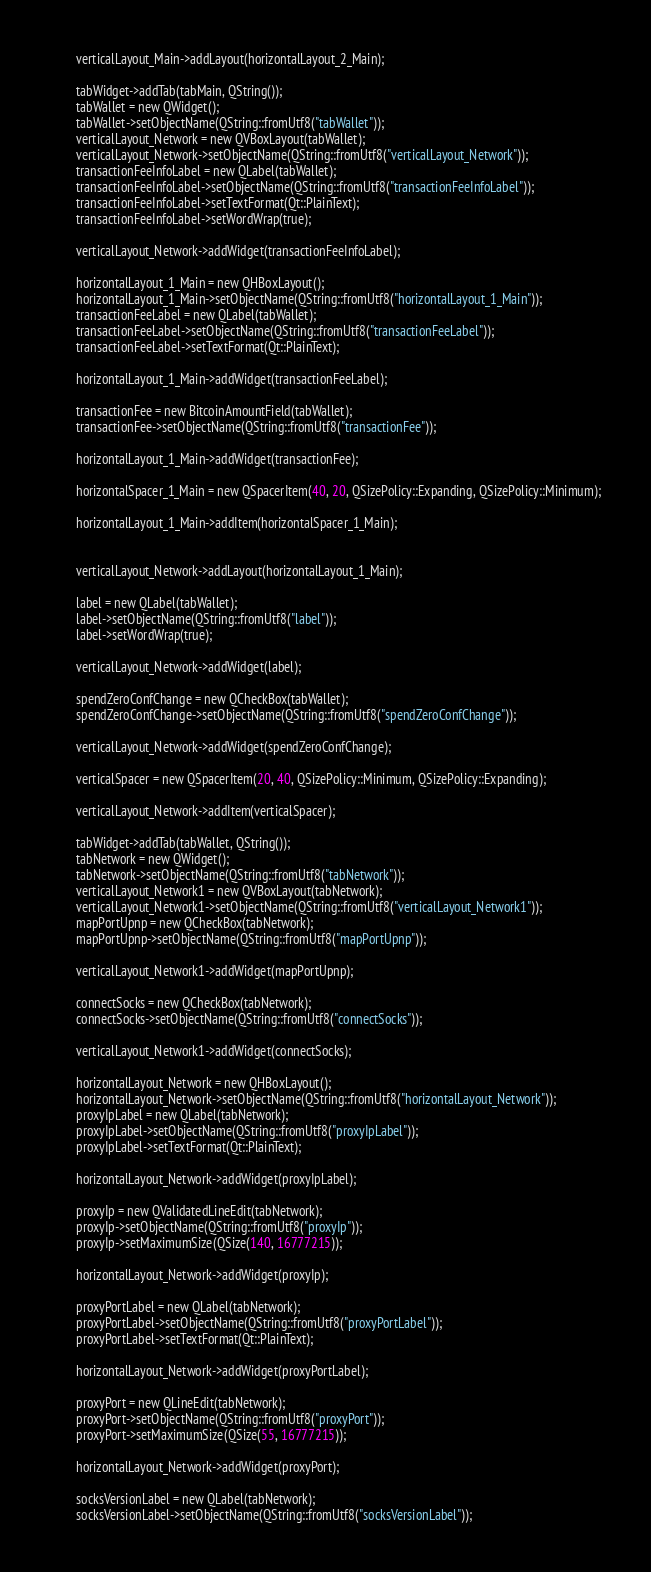Convert code to text. <code><loc_0><loc_0><loc_500><loc_500><_C_>        verticalLayout_Main->addLayout(horizontalLayout_2_Main);

        tabWidget->addTab(tabMain, QString());
        tabWallet = new QWidget();
        tabWallet->setObjectName(QString::fromUtf8("tabWallet"));
        verticalLayout_Network = new QVBoxLayout(tabWallet);
        verticalLayout_Network->setObjectName(QString::fromUtf8("verticalLayout_Network"));
        transactionFeeInfoLabel = new QLabel(tabWallet);
        transactionFeeInfoLabel->setObjectName(QString::fromUtf8("transactionFeeInfoLabel"));
        transactionFeeInfoLabel->setTextFormat(Qt::PlainText);
        transactionFeeInfoLabel->setWordWrap(true);

        verticalLayout_Network->addWidget(transactionFeeInfoLabel);

        horizontalLayout_1_Main = new QHBoxLayout();
        horizontalLayout_1_Main->setObjectName(QString::fromUtf8("horizontalLayout_1_Main"));
        transactionFeeLabel = new QLabel(tabWallet);
        transactionFeeLabel->setObjectName(QString::fromUtf8("transactionFeeLabel"));
        transactionFeeLabel->setTextFormat(Qt::PlainText);

        horizontalLayout_1_Main->addWidget(transactionFeeLabel);

        transactionFee = new BitcoinAmountField(tabWallet);
        transactionFee->setObjectName(QString::fromUtf8("transactionFee"));

        horizontalLayout_1_Main->addWidget(transactionFee);

        horizontalSpacer_1_Main = new QSpacerItem(40, 20, QSizePolicy::Expanding, QSizePolicy::Minimum);

        horizontalLayout_1_Main->addItem(horizontalSpacer_1_Main);


        verticalLayout_Network->addLayout(horizontalLayout_1_Main);

        label = new QLabel(tabWallet);
        label->setObjectName(QString::fromUtf8("label"));
        label->setWordWrap(true);

        verticalLayout_Network->addWidget(label);

        spendZeroConfChange = new QCheckBox(tabWallet);
        spendZeroConfChange->setObjectName(QString::fromUtf8("spendZeroConfChange"));

        verticalLayout_Network->addWidget(spendZeroConfChange);

        verticalSpacer = new QSpacerItem(20, 40, QSizePolicy::Minimum, QSizePolicy::Expanding);

        verticalLayout_Network->addItem(verticalSpacer);

        tabWidget->addTab(tabWallet, QString());
        tabNetwork = new QWidget();
        tabNetwork->setObjectName(QString::fromUtf8("tabNetwork"));
        verticalLayout_Network1 = new QVBoxLayout(tabNetwork);
        verticalLayout_Network1->setObjectName(QString::fromUtf8("verticalLayout_Network1"));
        mapPortUpnp = new QCheckBox(tabNetwork);
        mapPortUpnp->setObjectName(QString::fromUtf8("mapPortUpnp"));

        verticalLayout_Network1->addWidget(mapPortUpnp);

        connectSocks = new QCheckBox(tabNetwork);
        connectSocks->setObjectName(QString::fromUtf8("connectSocks"));

        verticalLayout_Network1->addWidget(connectSocks);

        horizontalLayout_Network = new QHBoxLayout();
        horizontalLayout_Network->setObjectName(QString::fromUtf8("horizontalLayout_Network"));
        proxyIpLabel = new QLabel(tabNetwork);
        proxyIpLabel->setObjectName(QString::fromUtf8("proxyIpLabel"));
        proxyIpLabel->setTextFormat(Qt::PlainText);

        horizontalLayout_Network->addWidget(proxyIpLabel);

        proxyIp = new QValidatedLineEdit(tabNetwork);
        proxyIp->setObjectName(QString::fromUtf8("proxyIp"));
        proxyIp->setMaximumSize(QSize(140, 16777215));

        horizontalLayout_Network->addWidget(proxyIp);

        proxyPortLabel = new QLabel(tabNetwork);
        proxyPortLabel->setObjectName(QString::fromUtf8("proxyPortLabel"));
        proxyPortLabel->setTextFormat(Qt::PlainText);

        horizontalLayout_Network->addWidget(proxyPortLabel);

        proxyPort = new QLineEdit(tabNetwork);
        proxyPort->setObjectName(QString::fromUtf8("proxyPort"));
        proxyPort->setMaximumSize(QSize(55, 16777215));

        horizontalLayout_Network->addWidget(proxyPort);

        socksVersionLabel = new QLabel(tabNetwork);
        socksVersionLabel->setObjectName(QString::fromUtf8("socksVersionLabel"));</code> 